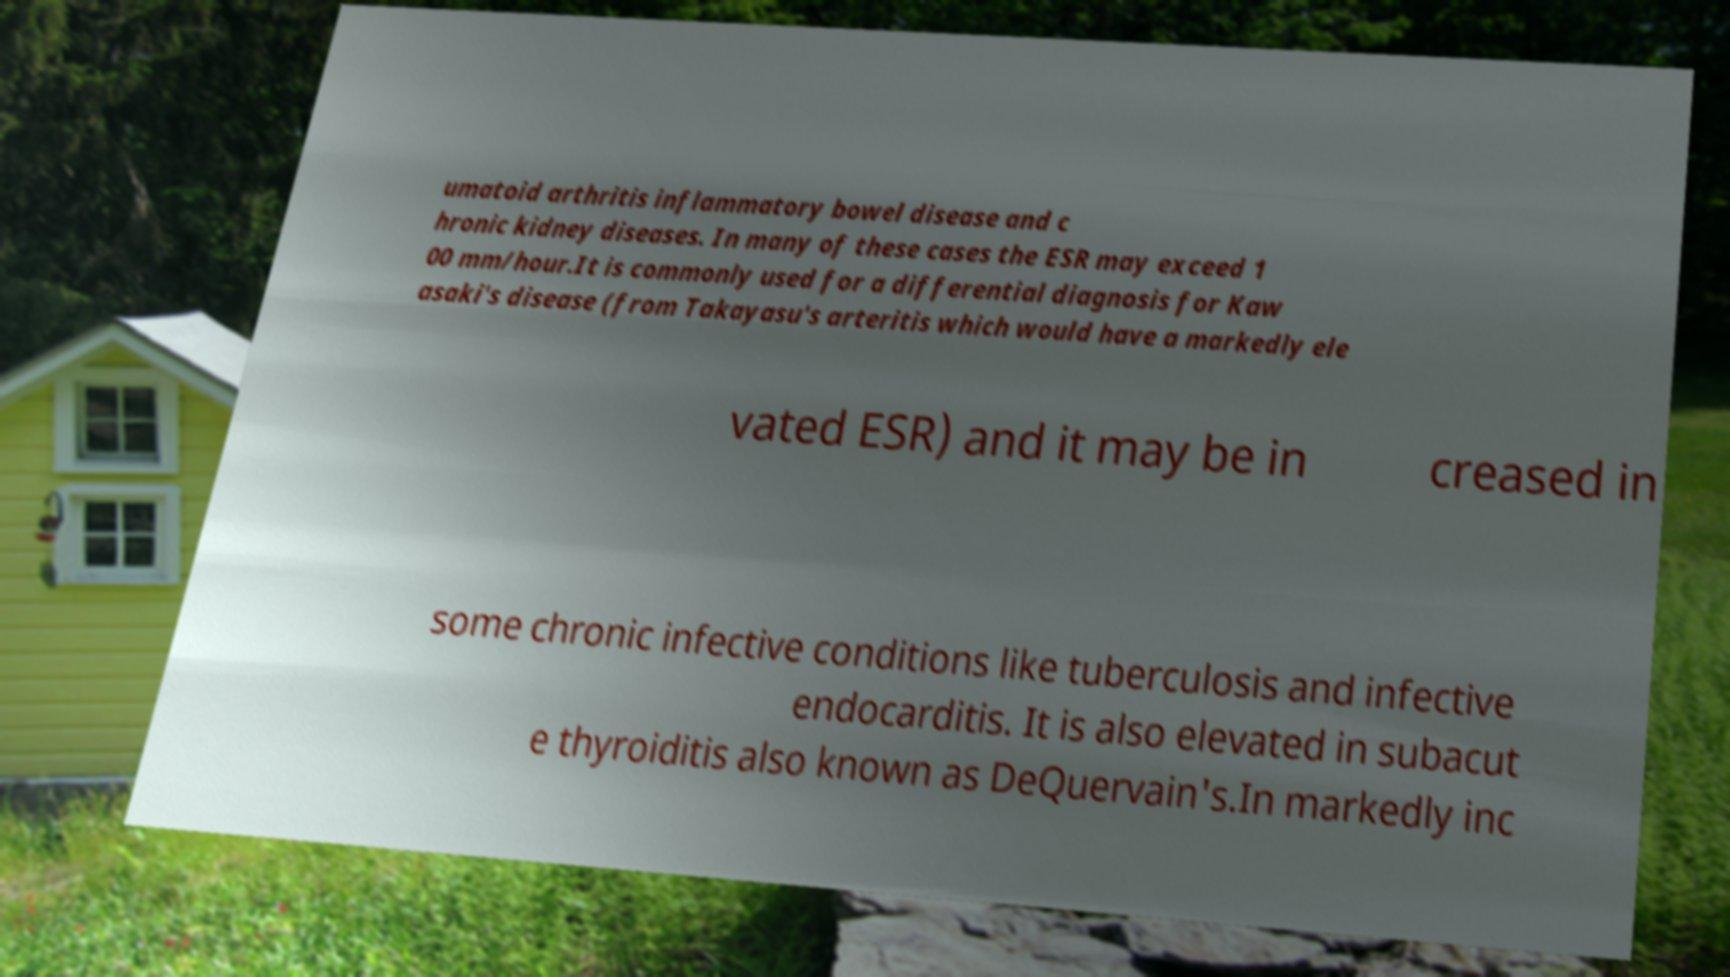For documentation purposes, I need the text within this image transcribed. Could you provide that? umatoid arthritis inflammatory bowel disease and c hronic kidney diseases. In many of these cases the ESR may exceed 1 00 mm/hour.It is commonly used for a differential diagnosis for Kaw asaki's disease (from Takayasu's arteritis which would have a markedly ele vated ESR) and it may be in creased in some chronic infective conditions like tuberculosis and infective endocarditis. It is also elevated in subacut e thyroiditis also known as DeQuervain's.In markedly inc 